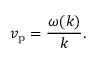<formula> <loc_0><loc_0><loc_500><loc_500>v _ { p } = { \frac { \omega ( k ) } { k } } .</formula> 